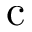Convert formula to latex. <formula><loc_0><loc_0><loc_500><loc_500>c</formula> 